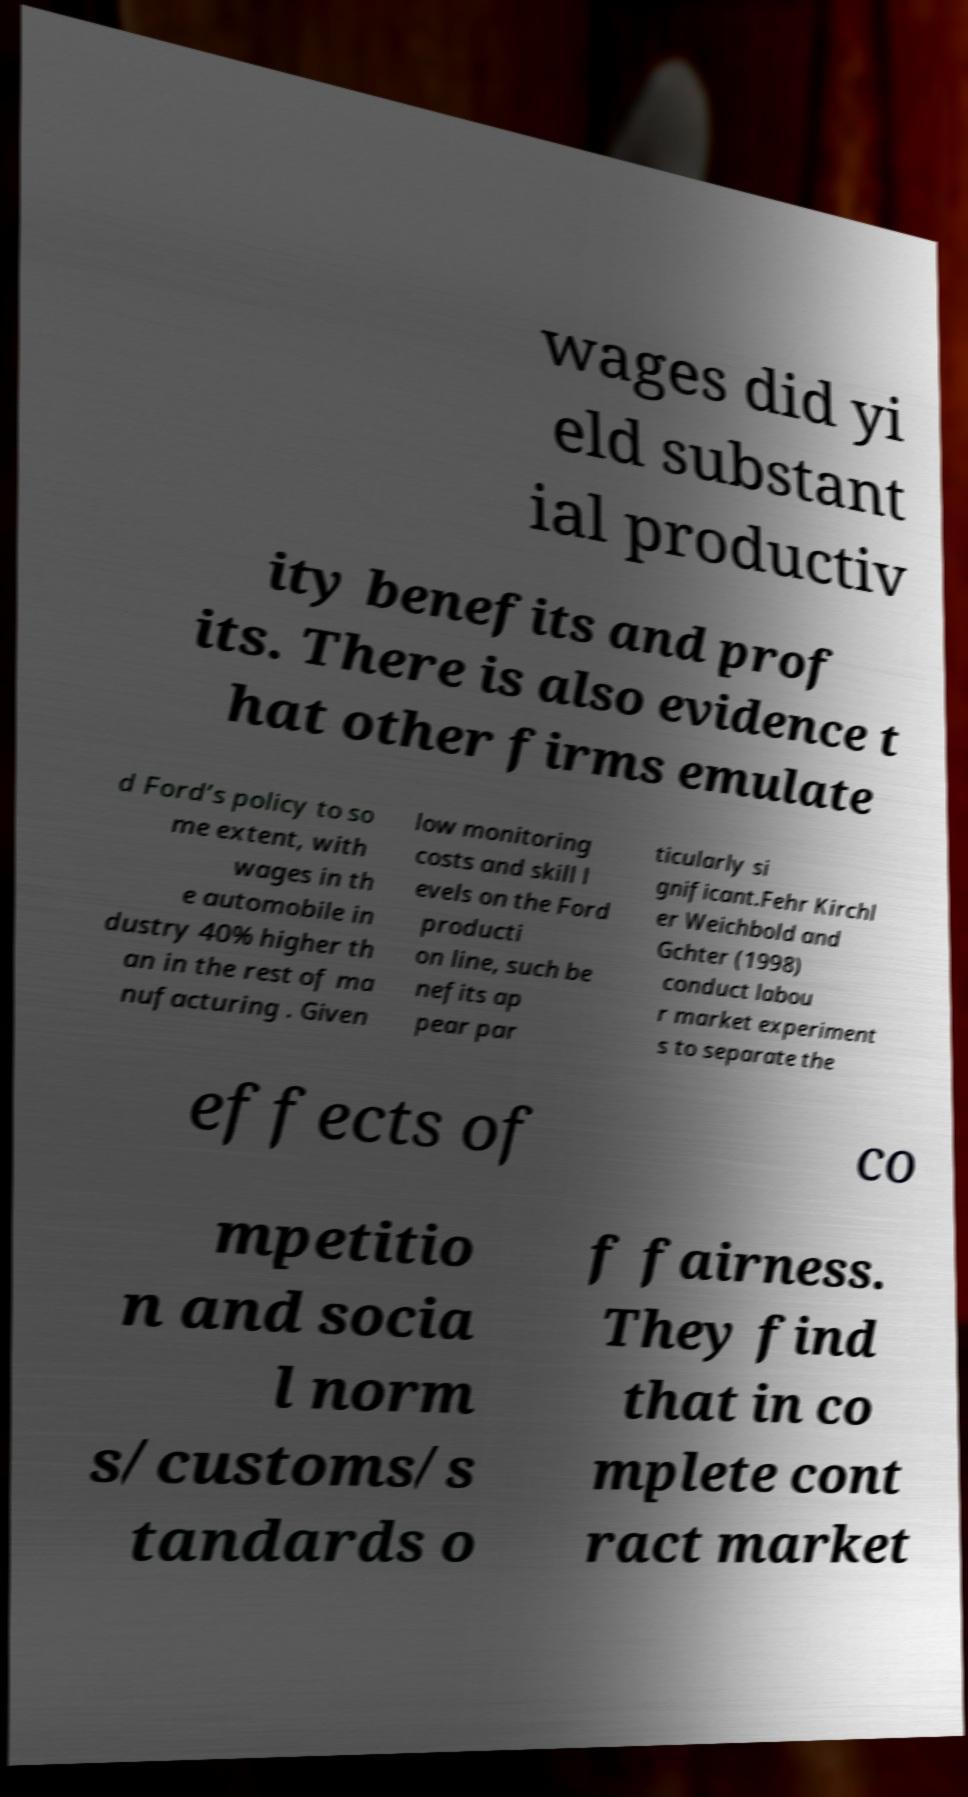Please read and relay the text visible in this image. What does it say? wages did yi eld substant ial productiv ity benefits and prof its. There is also evidence t hat other firms emulate d Ford’s policy to so me extent, with wages in th e automobile in dustry 40% higher th an in the rest of ma nufacturing . Given low monitoring costs and skill l evels on the Ford producti on line, such be nefits ap pear par ticularly si gnificant.Fehr Kirchl er Weichbold and Gchter (1998) conduct labou r market experiment s to separate the effects of co mpetitio n and socia l norm s/customs/s tandards o f fairness. They find that in co mplete cont ract market 